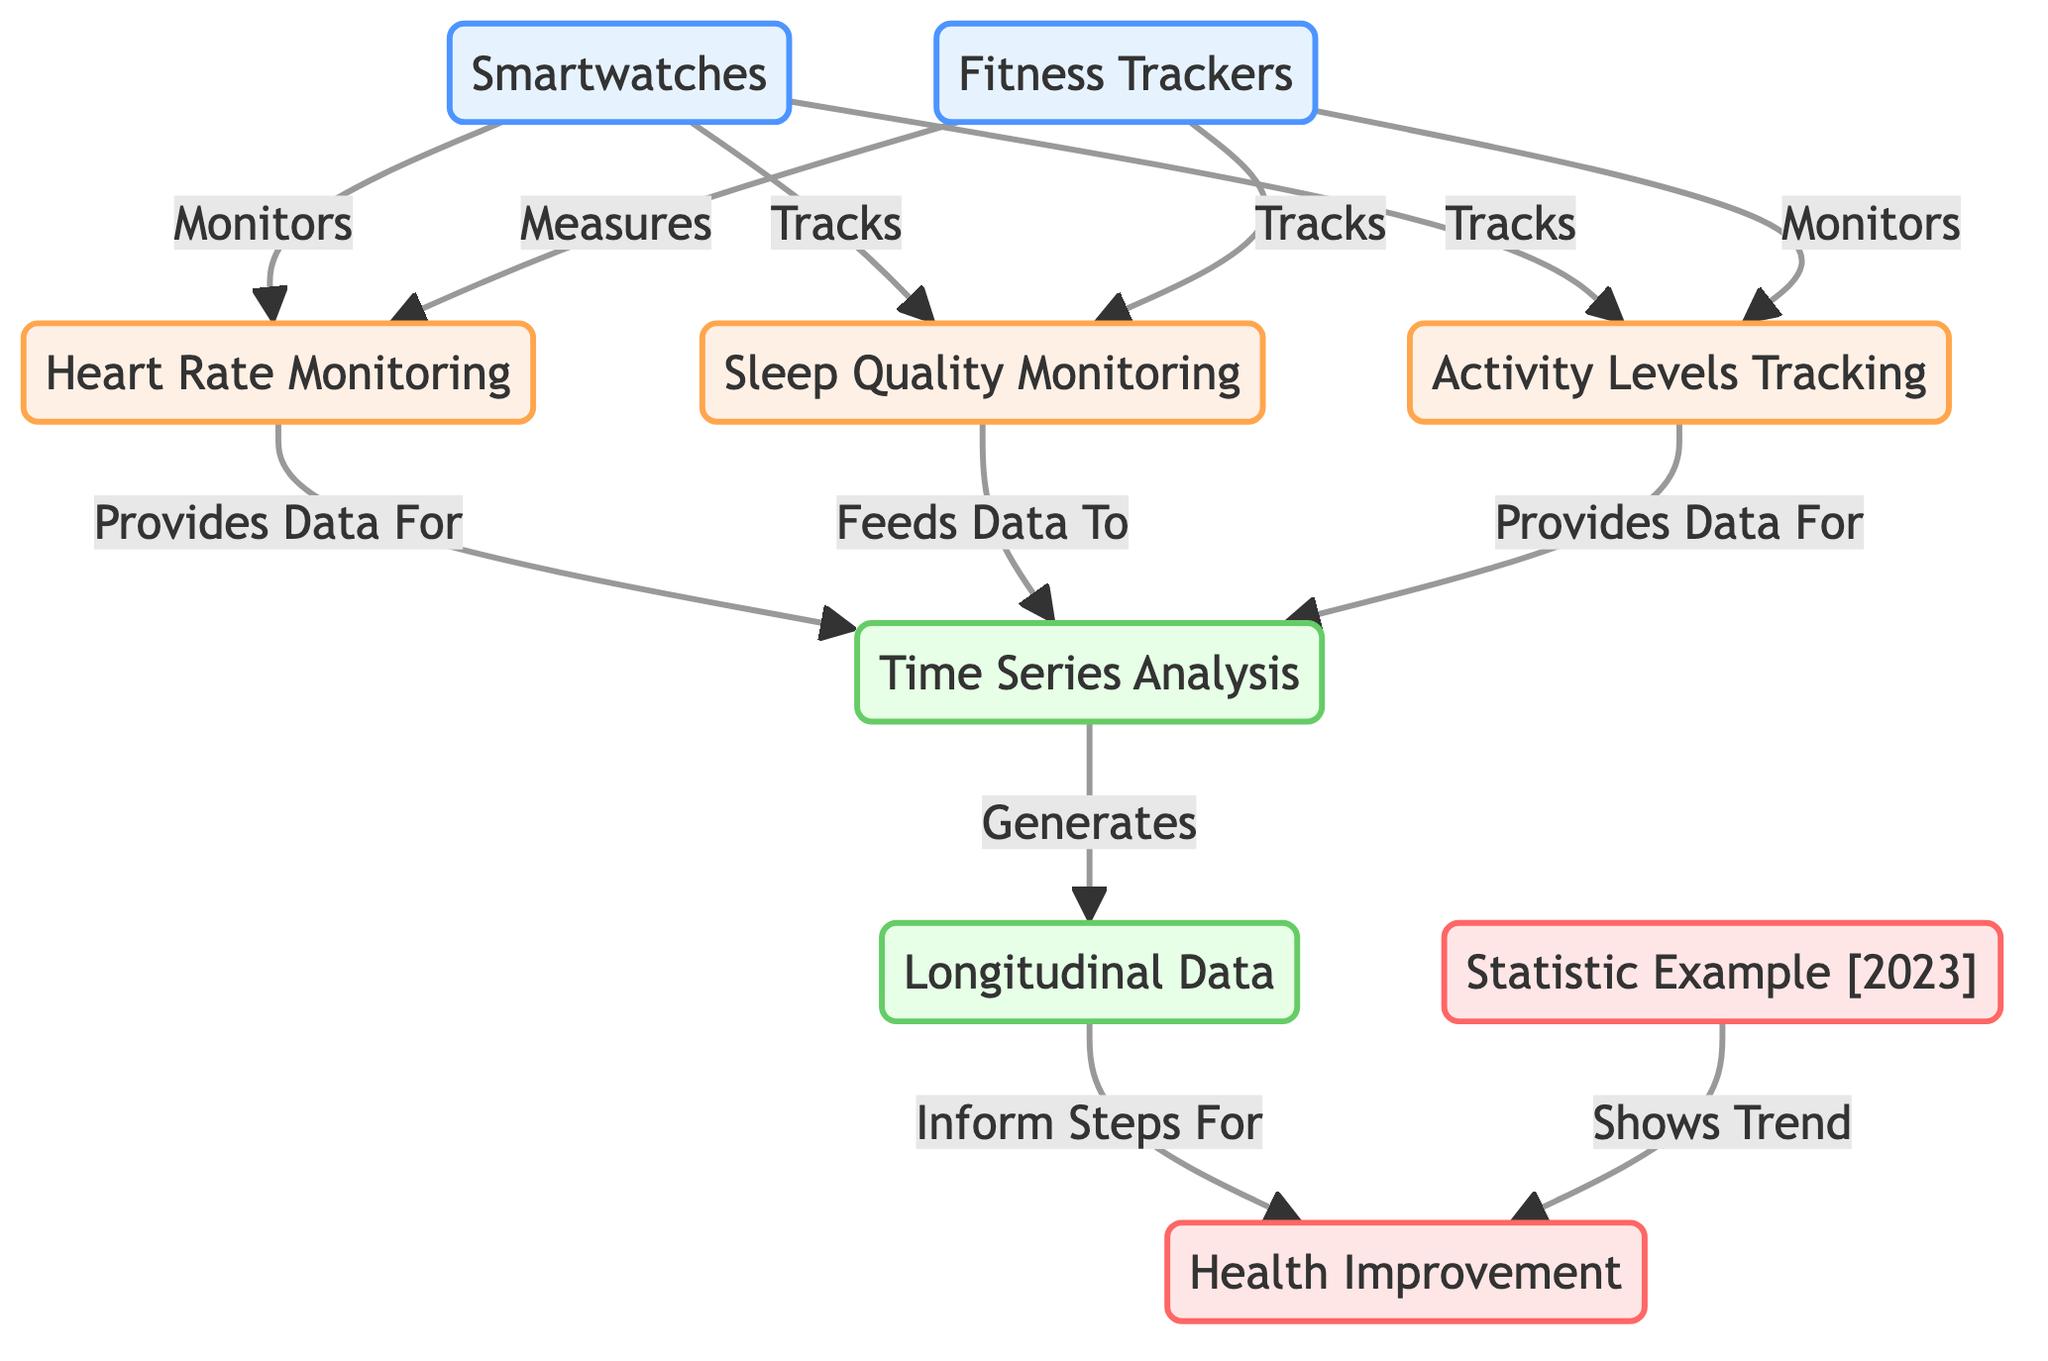What devices are included in the diagram? The diagram features two devices: Smartwatches and Fitness Trackers, which are labeled at the top as part of the device category.
Answer: Smartwatches, Fitness Trackers What type of monitoring do Smartwatches perform? Smartwatches are shown to monitor heart rate, track sleep quality, and track activity levels, indicated by arrows leading from Smartwatches to the respective monitoring categories.
Answer: Heart Rate Monitoring, Sleep Quality Monitoring, Activity Levels Tracking How does Heart Rate Monitoring contribute to data analysis? Heart Rate Monitoring provides data for Time Series Analysis, as shown in the diagram where an arrow leads from Heart Rate Monitoring to Time Series Analysis.
Answer: Provides Data For What is the final outcome indicated in the diagram? The diagram concludes with Health Improvement as the main outcome, which results from the analysis of the data collected and trends shown.
Answer: Health Improvement What type of data analysis is performed based on the health metrics? The diagram illustrates that Time Series Analysis is used to analyze the health metrics collected from monitoring devices, leading to Longitudinal Data.
Answer: Time Series Analysis What does the Statistic Example [2023] show in relation to Health Improvement? The Statistic Example [2023] is linked to Health Improvement, indicating that it reflects trends observed in health improvements over time as facilitated by wearable technology.
Answer: Shows Trend In which section does Activity Levels Tracking feed data? Activity Levels Tracking feeds data to Time Series Analysis, as indicated by the direct arrow from Activity Levels Tracking to Time Series Analysis in the diagram.
Answer: Time Series Analysis How many types of monitoring are represented in the diagram? The diagram depicts three types of monitoring: Heart Rate Monitoring, Sleep Quality Monitoring, and Activity Levels Tracking, which can be counted in the monitoring section.
Answer: Three What is the relationship between Longitudinal Data and Health Improvement? Longitudinal Data informs steps for Health Improvement, shown by the arrow leading from Longitudinal Data to Health Improvement, indicating a direct relationship where analysis influences health outcomes.
Answer: Inform Steps For 